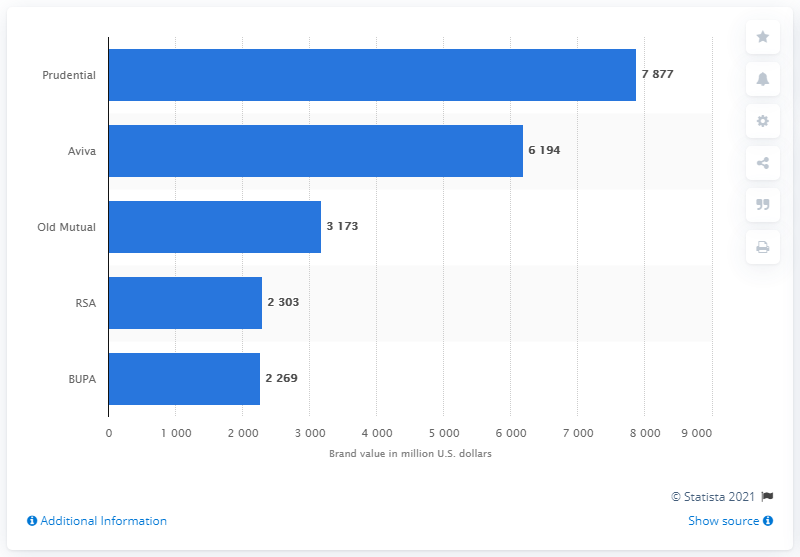Which company has the second-highest brand value according to this chart? Aviva has the second-highest brand value on the chart, valued at approximately $6.194 billion USD. 